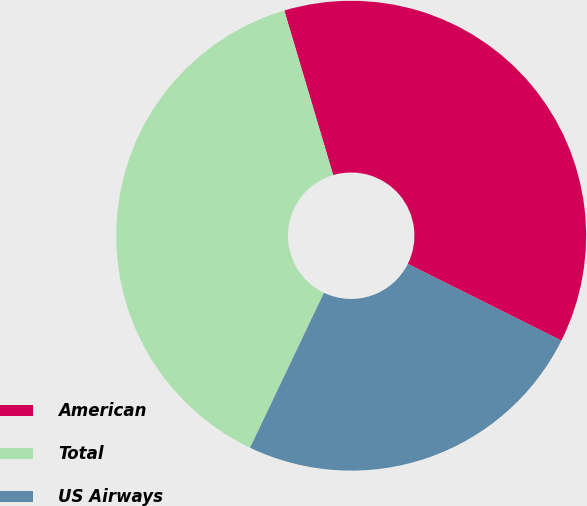Convert chart. <chart><loc_0><loc_0><loc_500><loc_500><pie_chart><fcel>American<fcel>Total<fcel>US Airways<nl><fcel>36.97%<fcel>38.32%<fcel>24.71%<nl></chart> 